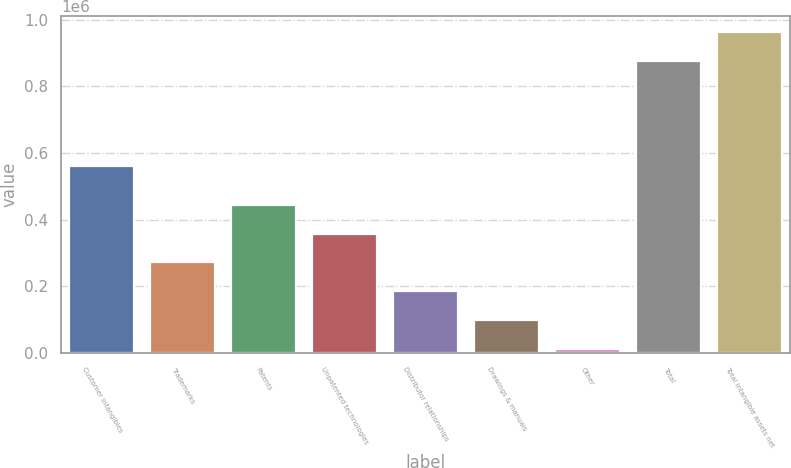<chart> <loc_0><loc_0><loc_500><loc_500><bar_chart><fcel>Customer intangibles<fcel>Trademarks<fcel>Patents<fcel>Unpatented technologies<fcel>Distributor relationships<fcel>Drawings & manuals<fcel>Other<fcel>Total<fcel>Total intangible assets net<nl><fcel>559447<fcel>271602<fcel>444652<fcel>358127<fcel>185078<fcel>98552.8<fcel>12028<fcel>877276<fcel>963801<nl></chart> 